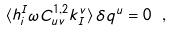Convert formula to latex. <formula><loc_0><loc_0><loc_500><loc_500>\langle h ^ { I } _ { i } \omega C _ { u v } ^ { 1 , 2 } k ^ { v } _ { I } \rangle \, \delta q ^ { u } = 0 \ ,</formula> 